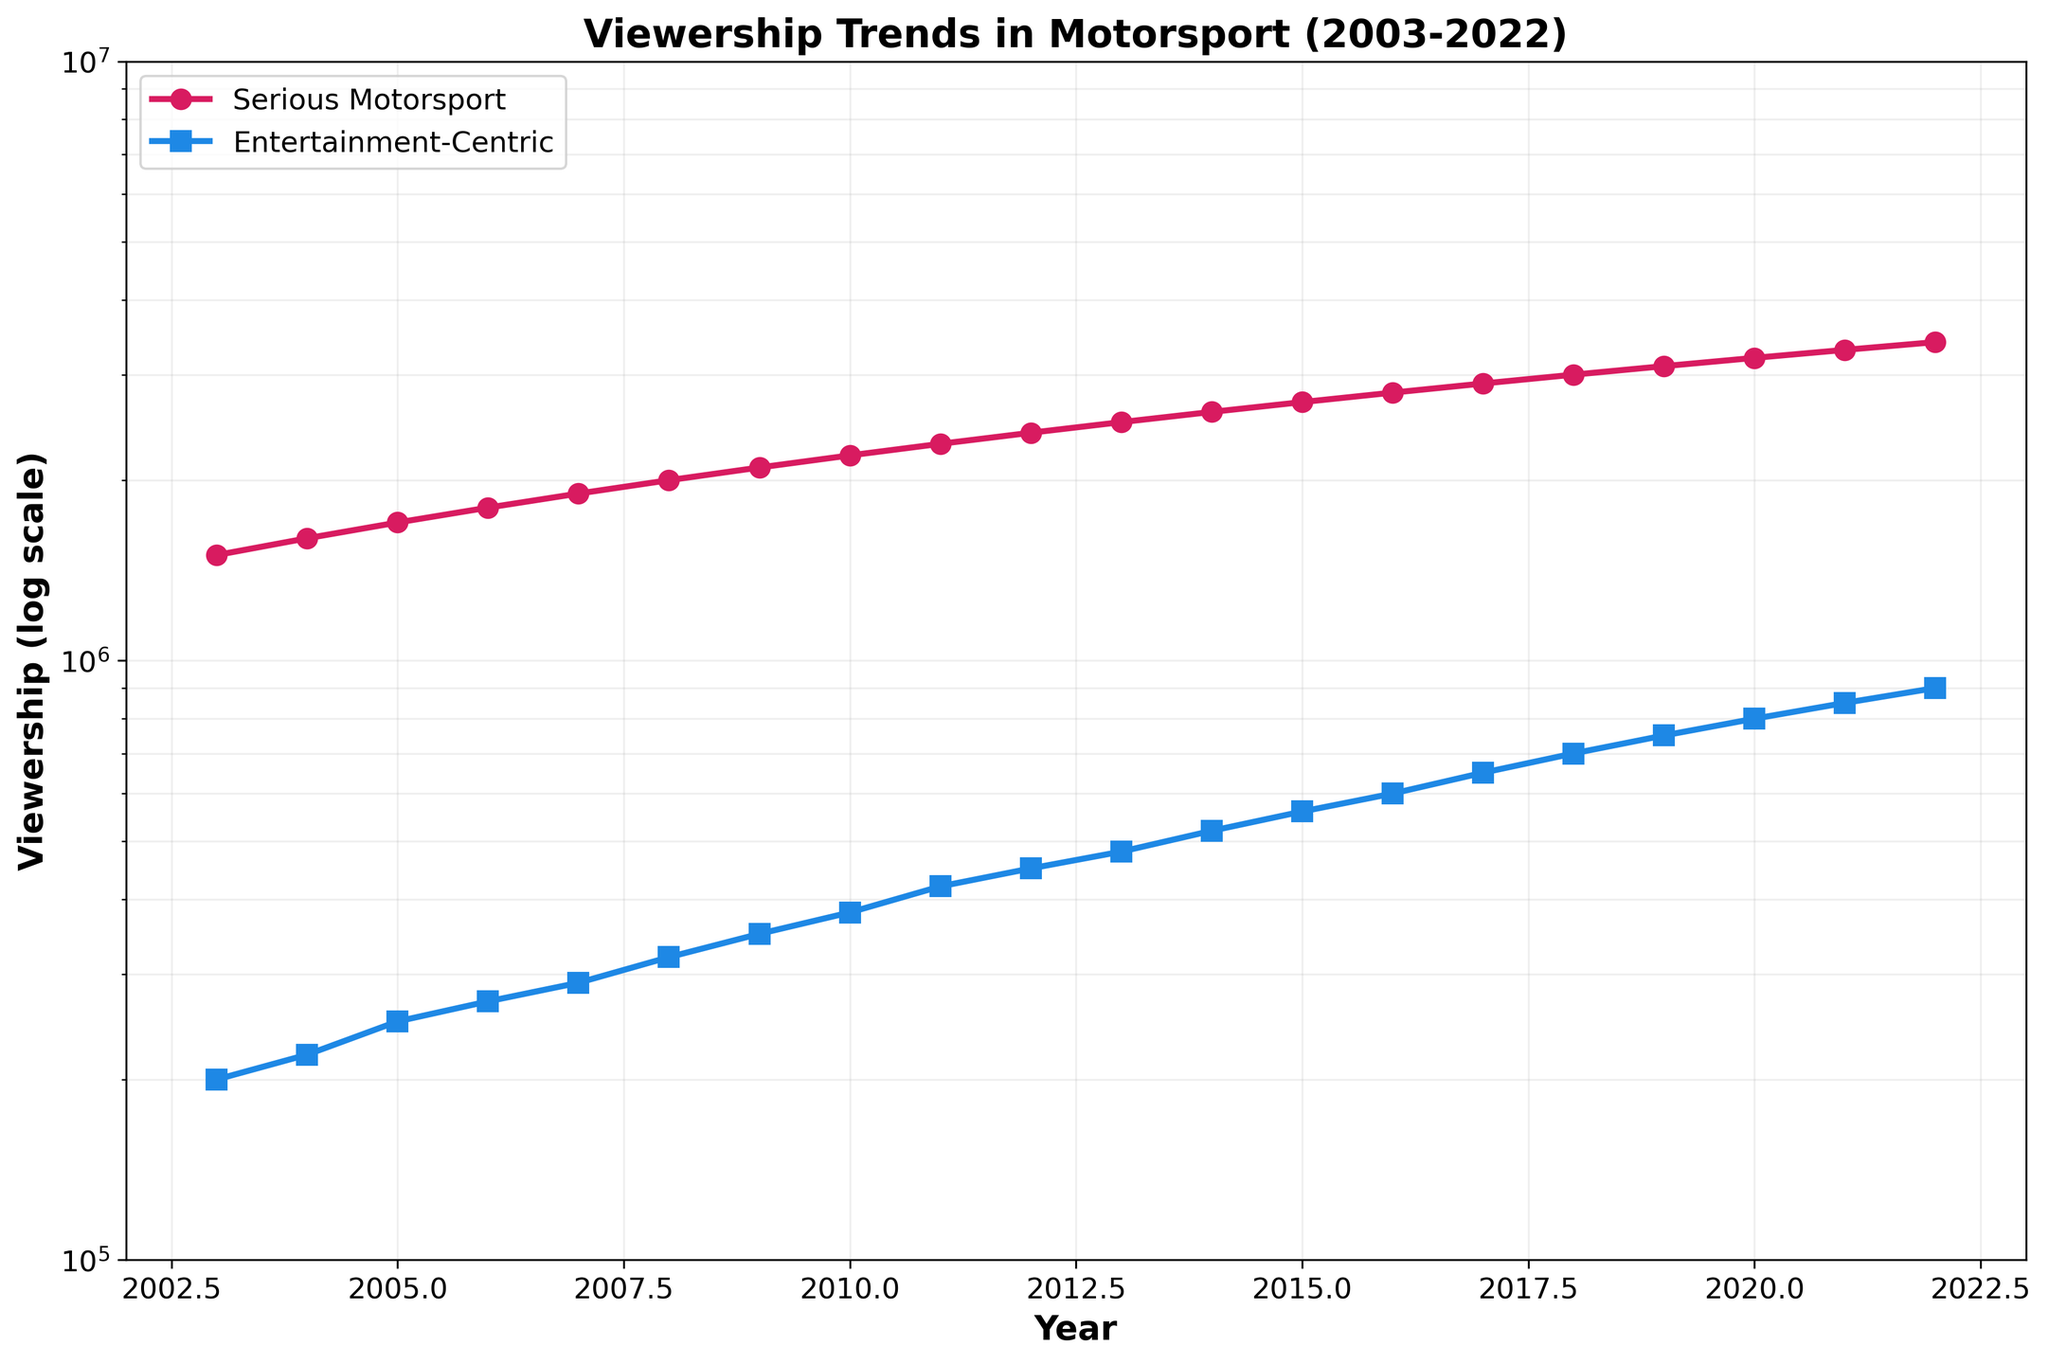What is the title of the plot? The title is located at the top center of the figure, indicating the subject of the visualized data. The exact text can be read directly from there.
Answer: Viewership Trends in Motorsport (2003-2022) What are the two categories compared in the plot? Looking at the legend on the figure, it shows two lines labeled for different types of motorsport events.
Answer: Serious Motorsport and Entertainment-Centric Motorsport What is the viewership rating for serious motorsport in 2010? By locating the point where the 'Serious Motorsport' line intersects with the year 2010 on the x-axis, and then reading the corresponding value on the y-axis, which is on a logarithmic scale.
Answer: 2,200,000 How does the viewership trend of entertainment-centric motorsport compare to that of serious motorsport from 2003 to 2022? Observe the overall direction and slope of the two lines; both lines appear to be increasing, but the rate can be visually compared.
Answer: Both are increasing, but serious motorsport starts higher and increases more steadily What is the viewership difference between serious and entertainment-centric motorsport in 2022? Locate the viewership values for 2022 for both categories and subtract the entertainment-centric viewership from the serious motorsport viewership.
Answer: 2,500,000 Which year shows the smallest difference in viewership between serious motorsport and entertainment-centric motorsport? For each year, calculate the difference between the two viewerships and identify the year with the smallest difference.
Answer: 2022 Has the difference in viewership between the two categories increased or decreased over time? Compare the difference in viewership at the start (2003) and at the end (2022) of the timeline by visually assessing how the gap between the two lines changes.
Answer: Decreased What is the approximate viewership of entertainment-centric motorsport in 2007? Locate the point for entertainment-centric motorsport in 2007, trace its position on the logarithmic y-axis.
Answer: 290,000 What is the average annual increase in viewership for serious motorsport from 2003 to 2022? Calculate the annual increase by taking the difference between the 2022 and 2003 values, then divide by the number of years (19).
Answer: 100,000 How many times greater was the serious motorsport viewership compared to entertainment-centric motorsport in 2003? Divide the serious motorsport viewership by the entertainment-centric motorsport viewership for the year 2003.
Answer: 7.5 